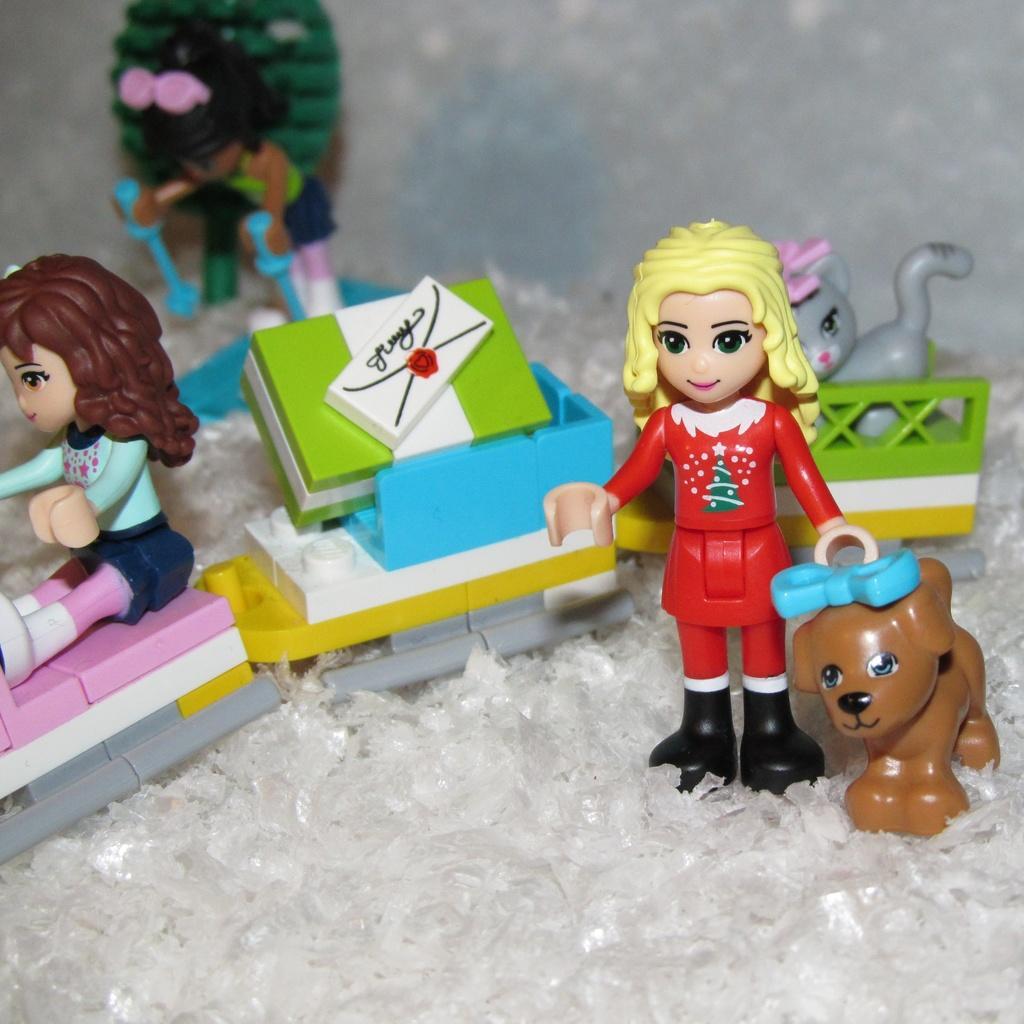In one or two sentences, can you explain what this image depicts? In this picture, we can see some plastic toys on the path. 